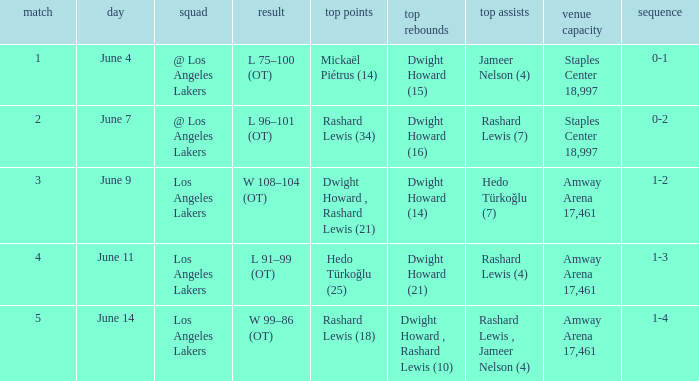What is High Assists, when High Rebounds is "Dwight Howard , Rashard Lewis (10)"? Rashard Lewis , Jameer Nelson (4). 